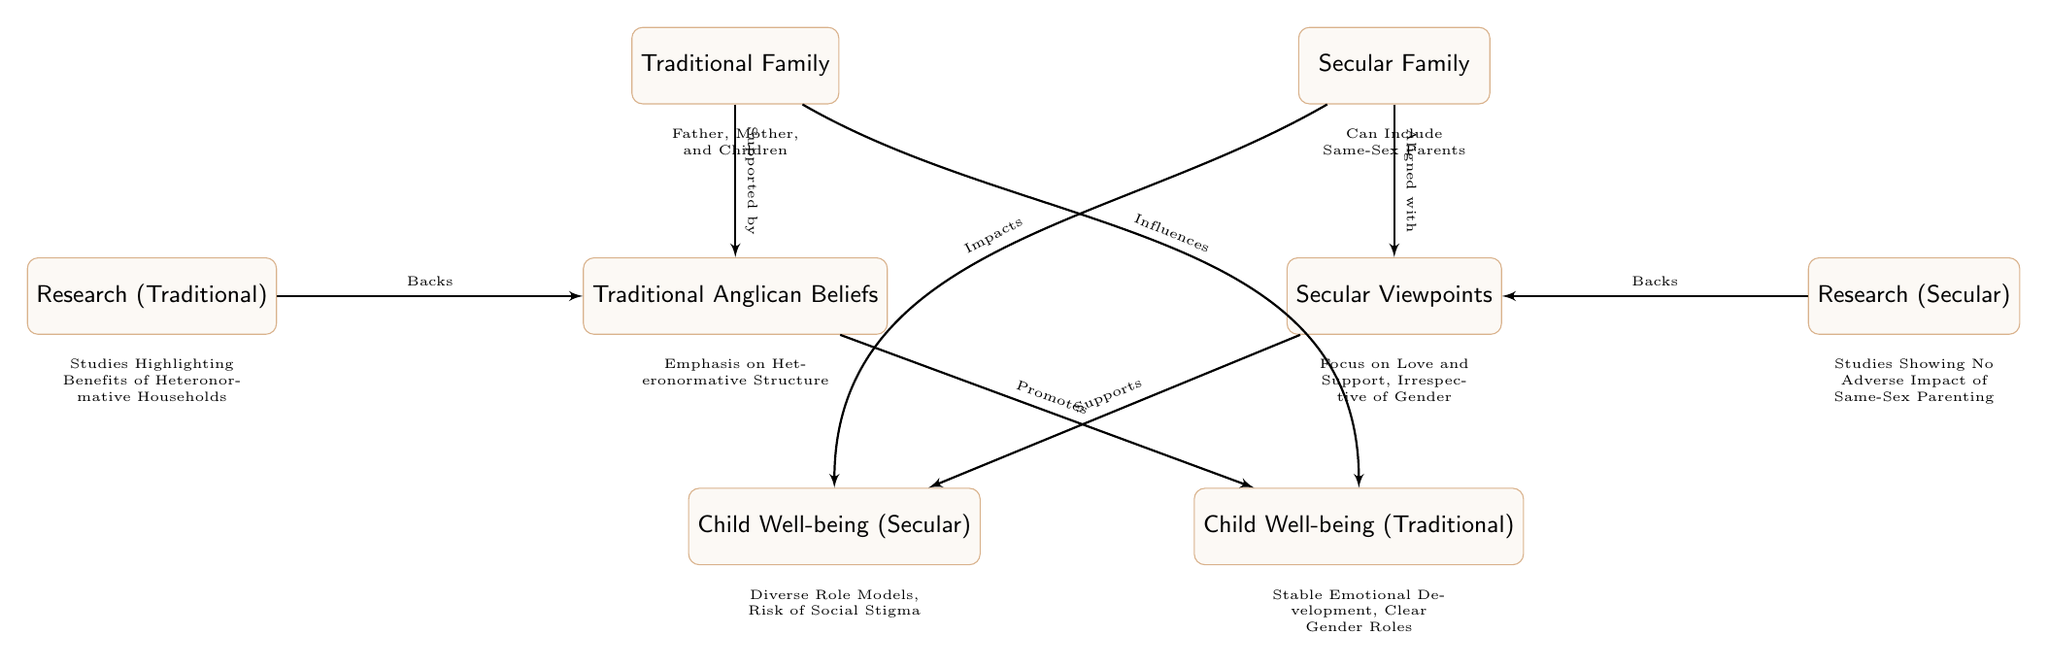What are the two family structures compared in the diagram? The diagram directly shows two main family structures: 'Traditional Family' and 'Secular Family', which are positioned on opposite sides of the diagram.
Answer: Traditional Family, Secular Family What does 'Traditional Anglican Beliefs' emphasize? The node for 'Traditional Anglican Beliefs' states "Emphasis on Heteronormative Structure", which indicates what the traditional beliefs focus on regarding family structure.
Answer: Emphasis on Heteronormative Structure Which type of research backs 'Secular Viewpoints'? The diagram indicates that 'Research (Secular)' backs 'Secular Viewpoints', showing the relationship between these two nodes.
Answer: Backs How many nodes are associated with 'Child Well-being (Traditional)'? There is one node labeled 'Child Well-being (Traditional)' connected with two lines, but it doesn't count as additional nodes; it is the sole node referring to traditional child well-being. Therefore, we have one main node in this context.
Answer: One What is the relationship between 'Traditional Family' and 'Child Well-being (Traditional)'? The lines illustrate that 'Traditional Family' 'Influences' 'Child Well-being (Traditional)' and also that 'Traditional Anglican Beliefs' 'Promotes' it, indicating a positive relationship from the family structure to child well-being.
Answer: Influences, Promotes What risk is mentioned about 'Child Well-being (Secular)'? The box labeled 'Child Well-being (Secular)' notes "Risk of Social Stigma", indicating a concern associated with this family type's impact on children.
Answer: Risk of Social Stigma How are 'Research (Traditional)' and 'Traditional Anglican Beliefs' connected? According to the diagram, 'Research (Traditional)' directly 'Backs' 'Traditional Anglican Beliefs', showing their supportive relationship.
Answer: Backs Which family structure can include same-sex parents? The 'Secular Family' node clearly states "Can Include Same-Sex Parents", directly indicating its inclusivity in terms of family composition.
Answer: Can Include Same-Sex Parents What promotes 'Child Well-being (Secular)'? 'Secular Viewpoints' is shown to 'Supports' 'Child Well-being (Secular)', highlighting its role in child emotional conditions in secular frameworks.
Answer: Supports 